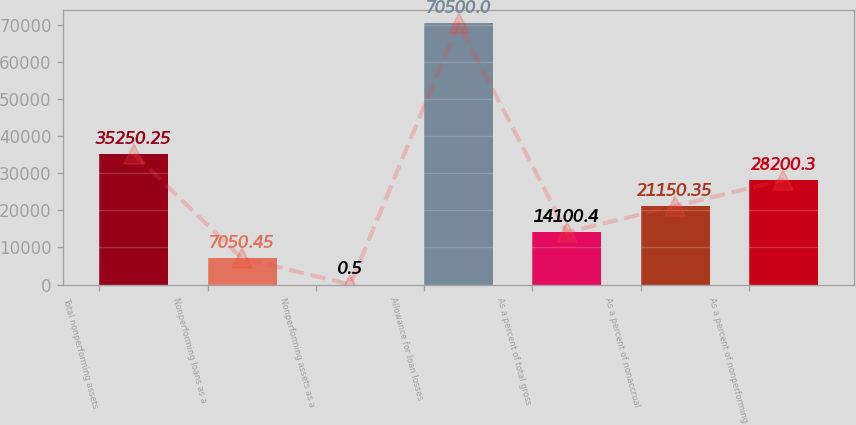<chart> <loc_0><loc_0><loc_500><loc_500><bar_chart><fcel>Total nonperforming assets<fcel>Nonperforming loans as a<fcel>Nonperforming assets as a<fcel>Allowance for loan losses<fcel>As a percent of total gross<fcel>As a percent of nonaccrual<fcel>As a percent of nonperforming<nl><fcel>35250.2<fcel>7050.45<fcel>0.5<fcel>70500<fcel>14100.4<fcel>21150.3<fcel>28200.3<nl></chart> 